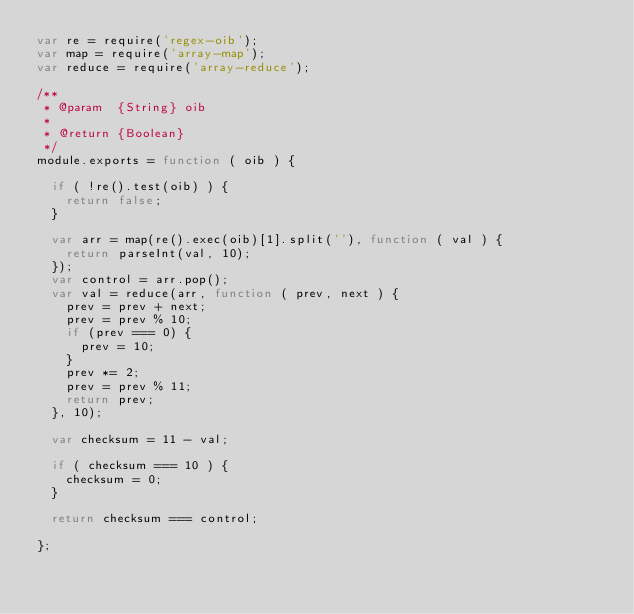Convert code to text. <code><loc_0><loc_0><loc_500><loc_500><_JavaScript_>var re = require('regex-oib');
var map = require('array-map');
var reduce = require('array-reduce');

/**
 * @param  {String} oib
 *
 * @return {Boolean}
 */
module.exports = function ( oib ) {

	if ( !re().test(oib) ) {
		return false;
	}

	var arr = map(re().exec(oib)[1].split(''), function ( val ) {
		return parseInt(val, 10);
	});
	var control = arr.pop();
	var val = reduce(arr, function ( prev, next ) {
		prev = prev + next;
		prev = prev % 10;
		if (prev === 0) {
			prev = 10;
		}
		prev *= 2;
		prev = prev % 11;
		return prev;
	}, 10);

	var checksum = 11 - val;

	if ( checksum === 10 ) {
		checksum = 0;
	}

	return checksum === control;

};
</code> 